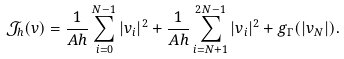<formula> <loc_0><loc_0><loc_500><loc_500>\mathcal { J } _ { h } ( v ) = \frac { 1 } { A h } \sum _ { i = 0 } ^ { N - 1 } | v _ { i } | ^ { 2 } + \frac { 1 } { A h } \sum _ { i = N + 1 } ^ { 2 N - 1 } | v _ { i } | ^ { 2 } + g _ { \Gamma } ( | v _ { N } | ) .</formula> 